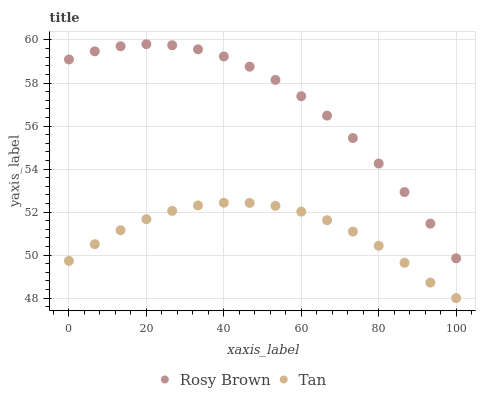Does Tan have the minimum area under the curve?
Answer yes or no. Yes. Does Rosy Brown have the maximum area under the curve?
Answer yes or no. Yes. Does Rosy Brown have the minimum area under the curve?
Answer yes or no. No. Is Tan the smoothest?
Answer yes or no. Yes. Is Rosy Brown the roughest?
Answer yes or no. Yes. Is Rosy Brown the smoothest?
Answer yes or no. No. Does Tan have the lowest value?
Answer yes or no. Yes. Does Rosy Brown have the lowest value?
Answer yes or no. No. Does Rosy Brown have the highest value?
Answer yes or no. Yes. Is Tan less than Rosy Brown?
Answer yes or no. Yes. Is Rosy Brown greater than Tan?
Answer yes or no. Yes. Does Tan intersect Rosy Brown?
Answer yes or no. No. 